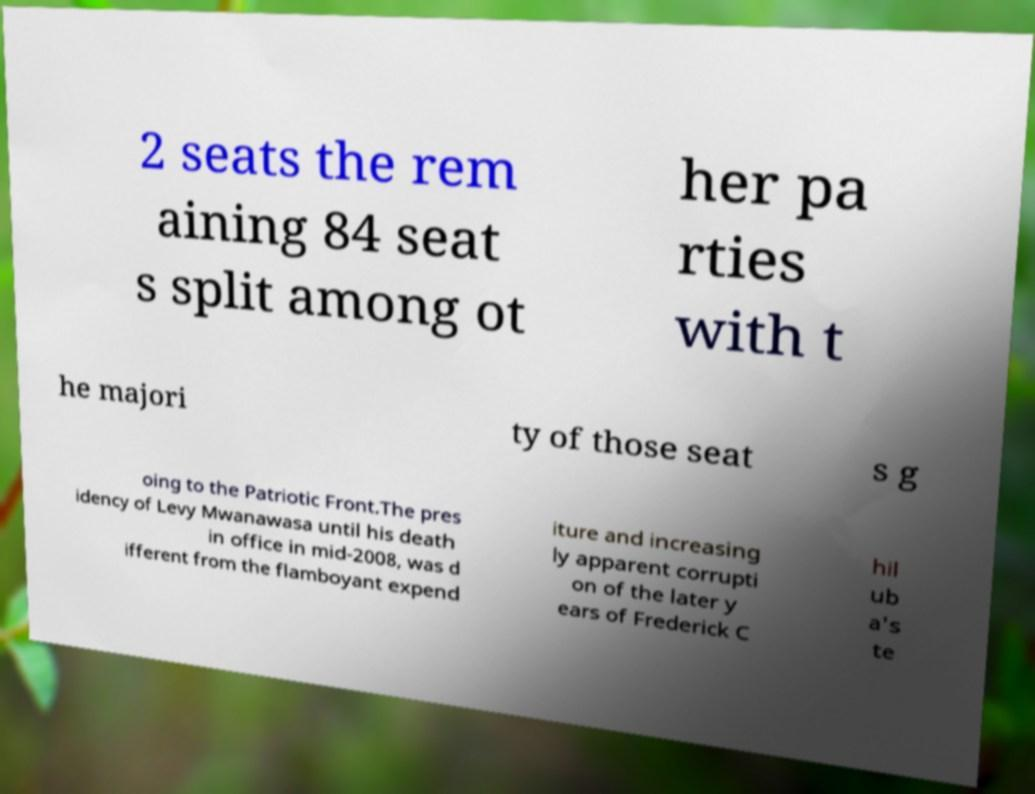For documentation purposes, I need the text within this image transcribed. Could you provide that? 2 seats the rem aining 84 seat s split among ot her pa rties with t he majori ty of those seat s g oing to the Patriotic Front.The pres idency of Levy Mwanawasa until his death in office in mid-2008, was d ifferent from the flamboyant expend iture and increasing ly apparent corrupti on of the later y ears of Frederick C hil ub a's te 